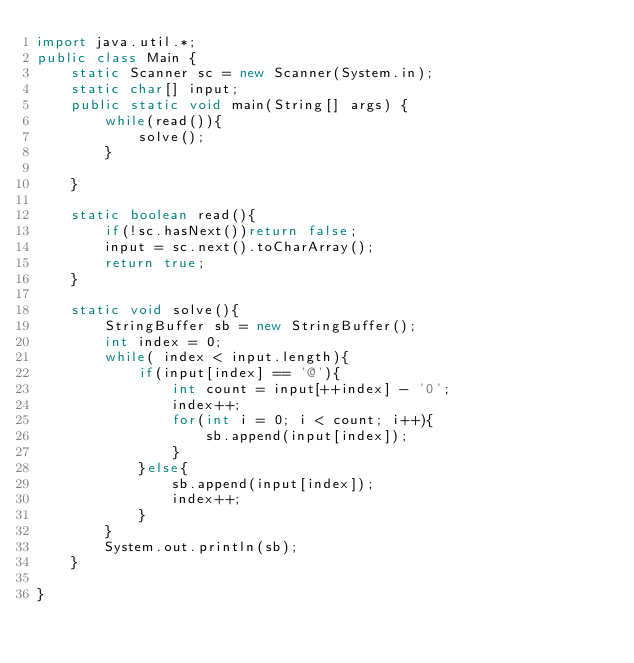Convert code to text. <code><loc_0><loc_0><loc_500><loc_500><_Java_>import java.util.*;
public class Main {
    static Scanner sc = new Scanner(System.in);
    static char[] input;
    public static void main(String[] args) {
        while(read()){
            solve();
        }

    }

    static boolean read(){
        if(!sc.hasNext())return false;
        input = sc.next().toCharArray();
        return true;
    }

    static void solve(){
        StringBuffer sb = new StringBuffer();
        int index = 0;
        while( index < input.length){
            if(input[index] == '@'){
                int count = input[++index] - '0';
                index++;
                for(int i = 0; i < count; i++){
                    sb.append(input[index]);
                }
            }else{
                sb.append(input[index]);
                index++;
            }
        }
        System.out.println(sb);
    }

}</code> 